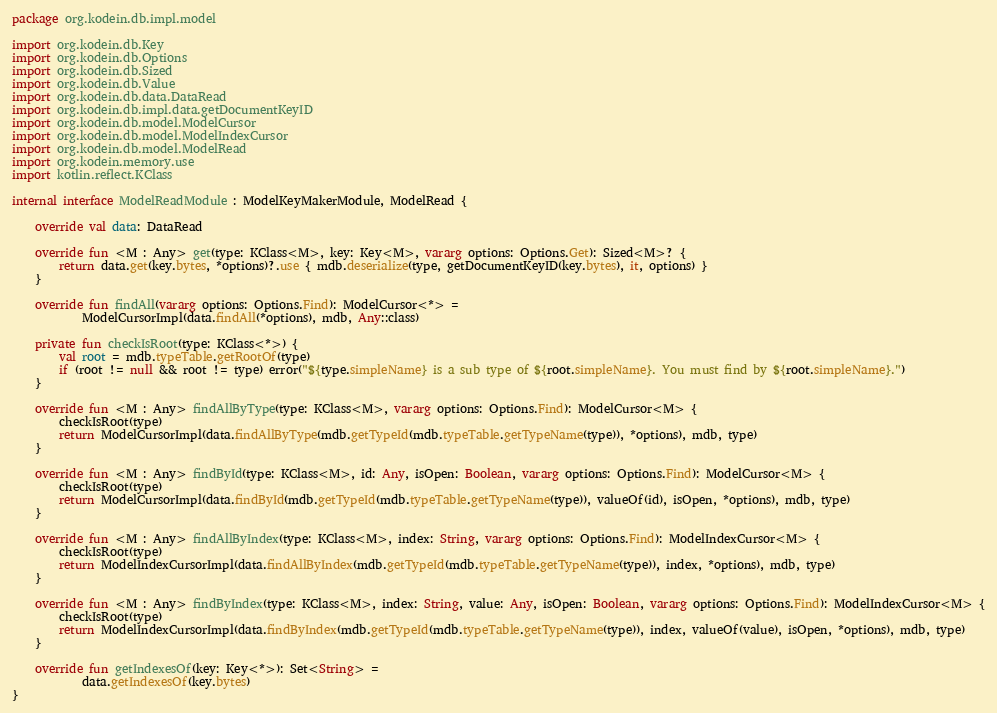<code> <loc_0><loc_0><loc_500><loc_500><_Kotlin_>package org.kodein.db.impl.model

import org.kodein.db.Key
import org.kodein.db.Options
import org.kodein.db.Sized
import org.kodein.db.Value
import org.kodein.db.data.DataRead
import org.kodein.db.impl.data.getDocumentKeyID
import org.kodein.db.model.ModelCursor
import org.kodein.db.model.ModelIndexCursor
import org.kodein.db.model.ModelRead
import org.kodein.memory.use
import kotlin.reflect.KClass

internal interface ModelReadModule : ModelKeyMakerModule, ModelRead {

    override val data: DataRead

    override fun <M : Any> get(type: KClass<M>, key: Key<M>, vararg options: Options.Get): Sized<M>? {
        return data.get(key.bytes, *options)?.use { mdb.deserialize(type, getDocumentKeyID(key.bytes), it, options) }
    }

    override fun findAll(vararg options: Options.Find): ModelCursor<*> =
            ModelCursorImpl(data.findAll(*options), mdb, Any::class)

    private fun checkIsRoot(type: KClass<*>) {
        val root = mdb.typeTable.getRootOf(type)
        if (root != null && root != type) error("${type.simpleName} is a sub type of ${root.simpleName}. You must find by ${root.simpleName}.")
    }

    override fun <M : Any> findAllByType(type: KClass<M>, vararg options: Options.Find): ModelCursor<M> {
        checkIsRoot(type)
        return ModelCursorImpl(data.findAllByType(mdb.getTypeId(mdb.typeTable.getTypeName(type)), *options), mdb, type)
    }

    override fun <M : Any> findById(type: KClass<M>, id: Any, isOpen: Boolean, vararg options: Options.Find): ModelCursor<M> {
        checkIsRoot(type)
        return ModelCursorImpl(data.findById(mdb.getTypeId(mdb.typeTable.getTypeName(type)), valueOf(id), isOpen, *options), mdb, type)
    }

    override fun <M : Any> findAllByIndex(type: KClass<M>, index: String, vararg options: Options.Find): ModelIndexCursor<M> {
        checkIsRoot(type)
        return ModelIndexCursorImpl(data.findAllByIndex(mdb.getTypeId(mdb.typeTable.getTypeName(type)), index, *options), mdb, type)
    }

    override fun <M : Any> findByIndex(type: KClass<M>, index: String, value: Any, isOpen: Boolean, vararg options: Options.Find): ModelIndexCursor<M> {
        checkIsRoot(type)
        return ModelIndexCursorImpl(data.findByIndex(mdb.getTypeId(mdb.typeTable.getTypeName(type)), index, valueOf(value), isOpen, *options), mdb, type)
    }

    override fun getIndexesOf(key: Key<*>): Set<String> =
            data.getIndexesOf(key.bytes)
}
</code> 